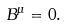Convert formula to latex. <formula><loc_0><loc_0><loc_500><loc_500>B ^ { \mu } = 0 .</formula> 